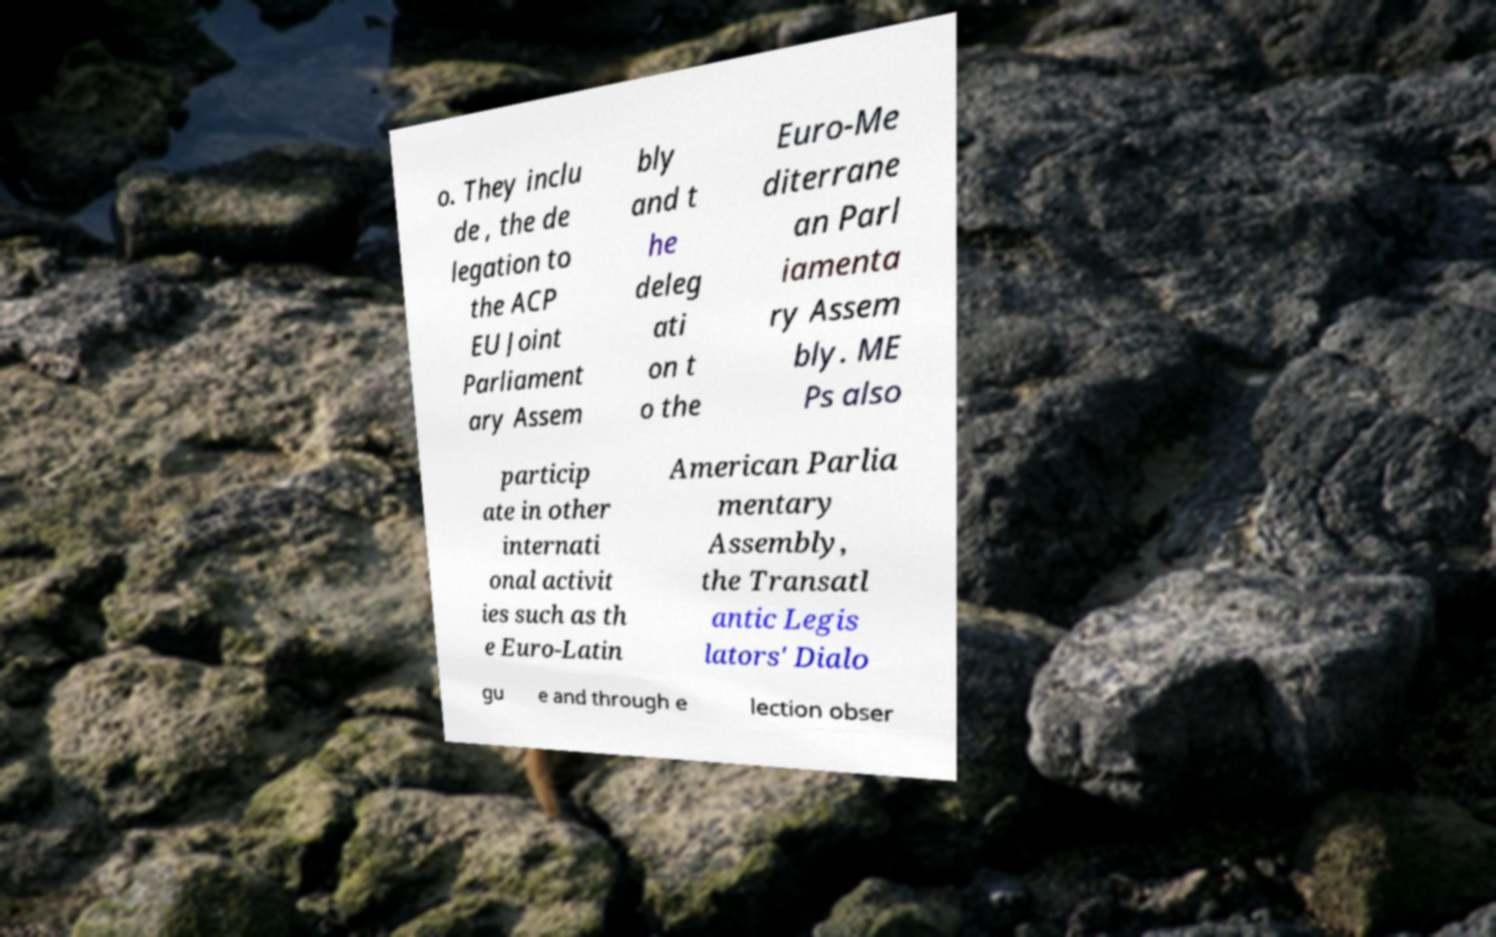Please read and relay the text visible in this image. What does it say? o. They inclu de , the de legation to the ACP EU Joint Parliament ary Assem bly and t he deleg ati on t o the Euro-Me diterrane an Parl iamenta ry Assem bly. ME Ps also particip ate in other internati onal activit ies such as th e Euro-Latin American Parlia mentary Assembly, the Transatl antic Legis lators' Dialo gu e and through e lection obser 